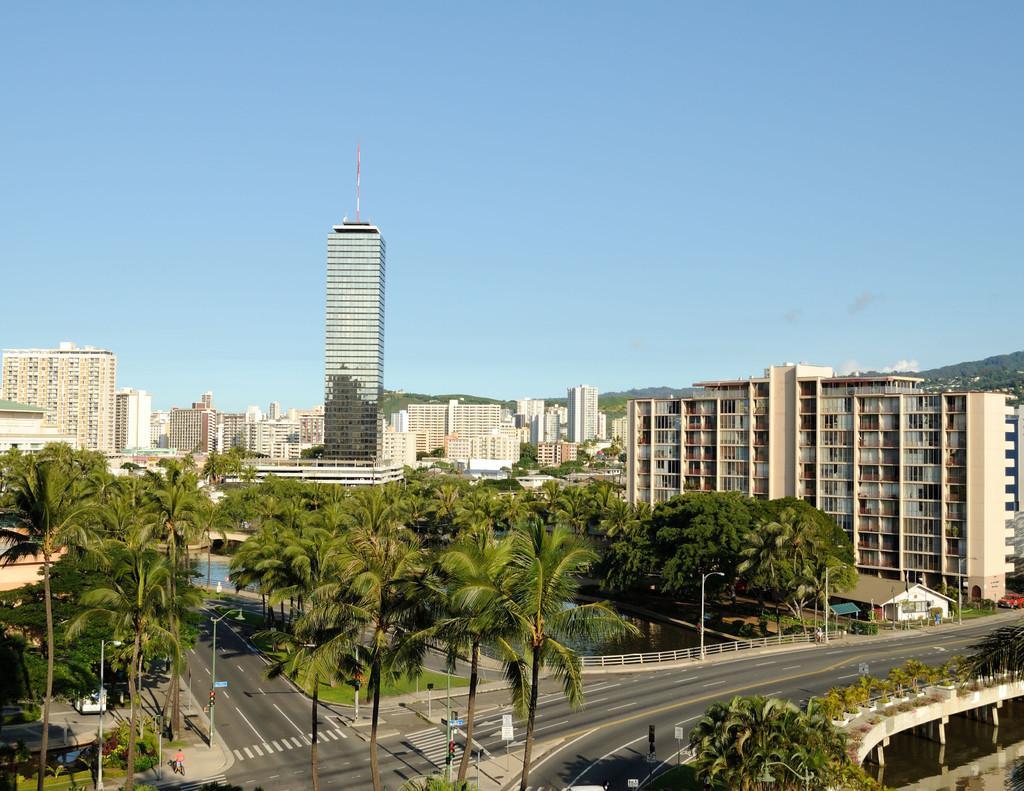Describe this image in one or two sentences. In this picture we can see skyscrapers and many buildings. At the bottom we can see the four way road, zebra crossing, sign boards, trees and bridge. On the right there is a shade near to the water. In the background we can see the mountains. In the bottom left corner we can see the group of persons were standing near to the road and trees. At the top there is a sky. 